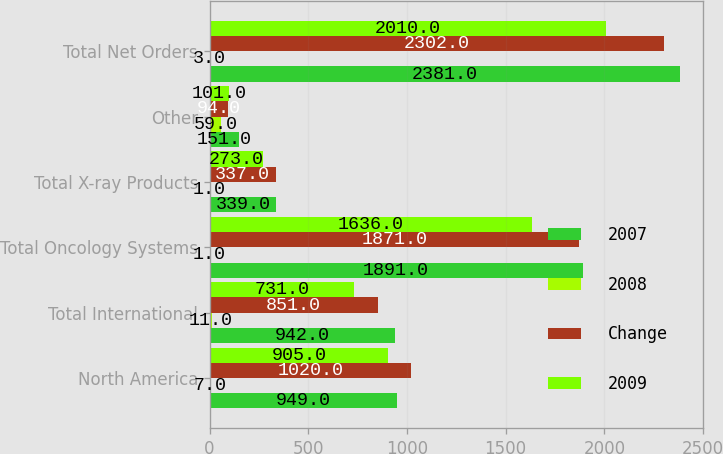Convert chart. <chart><loc_0><loc_0><loc_500><loc_500><stacked_bar_chart><ecel><fcel>North America<fcel>Total International<fcel>Total Oncology Systems<fcel>Total X-ray Products<fcel>Other<fcel>Total Net Orders<nl><fcel>2007<fcel>949<fcel>942<fcel>1891<fcel>339<fcel>151<fcel>2381<nl><fcel>2008<fcel>7<fcel>11<fcel>1<fcel>1<fcel>59<fcel>3<nl><fcel>Change<fcel>1020<fcel>851<fcel>1871<fcel>337<fcel>94<fcel>2302<nl><fcel>2009<fcel>905<fcel>731<fcel>1636<fcel>273<fcel>101<fcel>2010<nl></chart> 